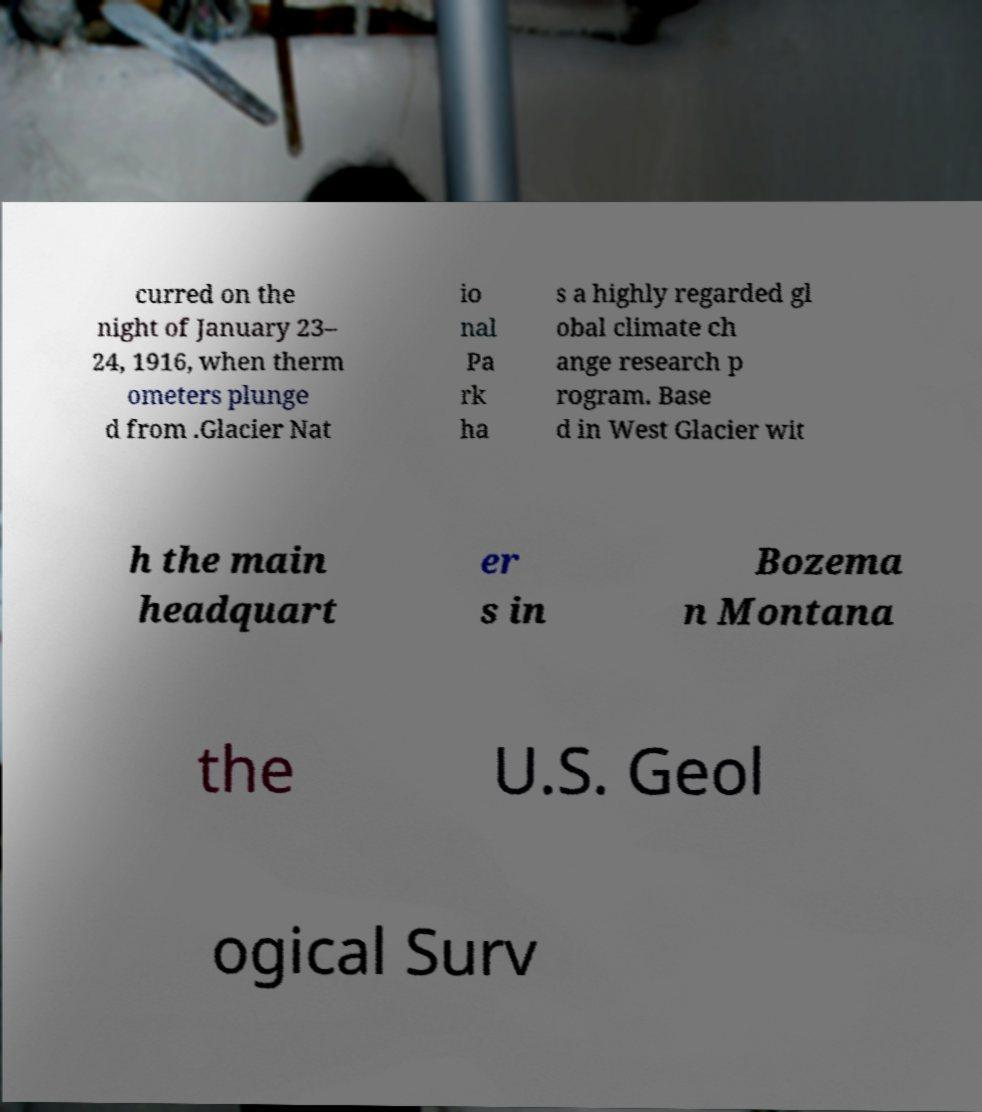Can you accurately transcribe the text from the provided image for me? curred on the night of January 23– 24, 1916, when therm ometers plunge d from .Glacier Nat io nal Pa rk ha s a highly regarded gl obal climate ch ange research p rogram. Base d in West Glacier wit h the main headquart er s in Bozema n Montana the U.S. Geol ogical Surv 